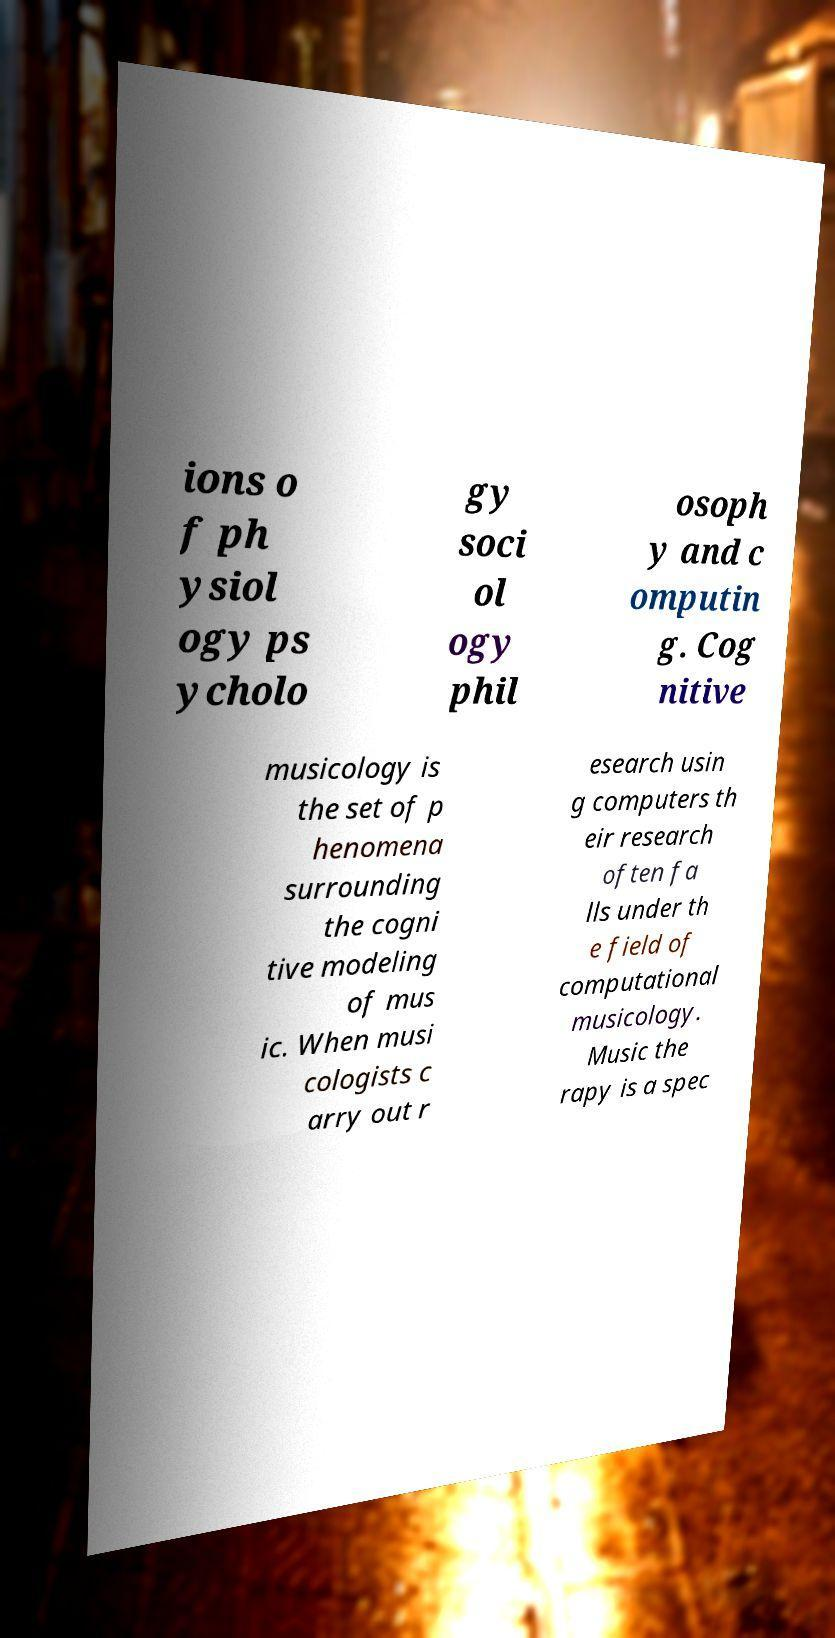Can you accurately transcribe the text from the provided image for me? ions o f ph ysiol ogy ps ycholo gy soci ol ogy phil osoph y and c omputin g. Cog nitive musicology is the set of p henomena surrounding the cogni tive modeling of mus ic. When musi cologists c arry out r esearch usin g computers th eir research often fa lls under th e field of computational musicology. Music the rapy is a spec 